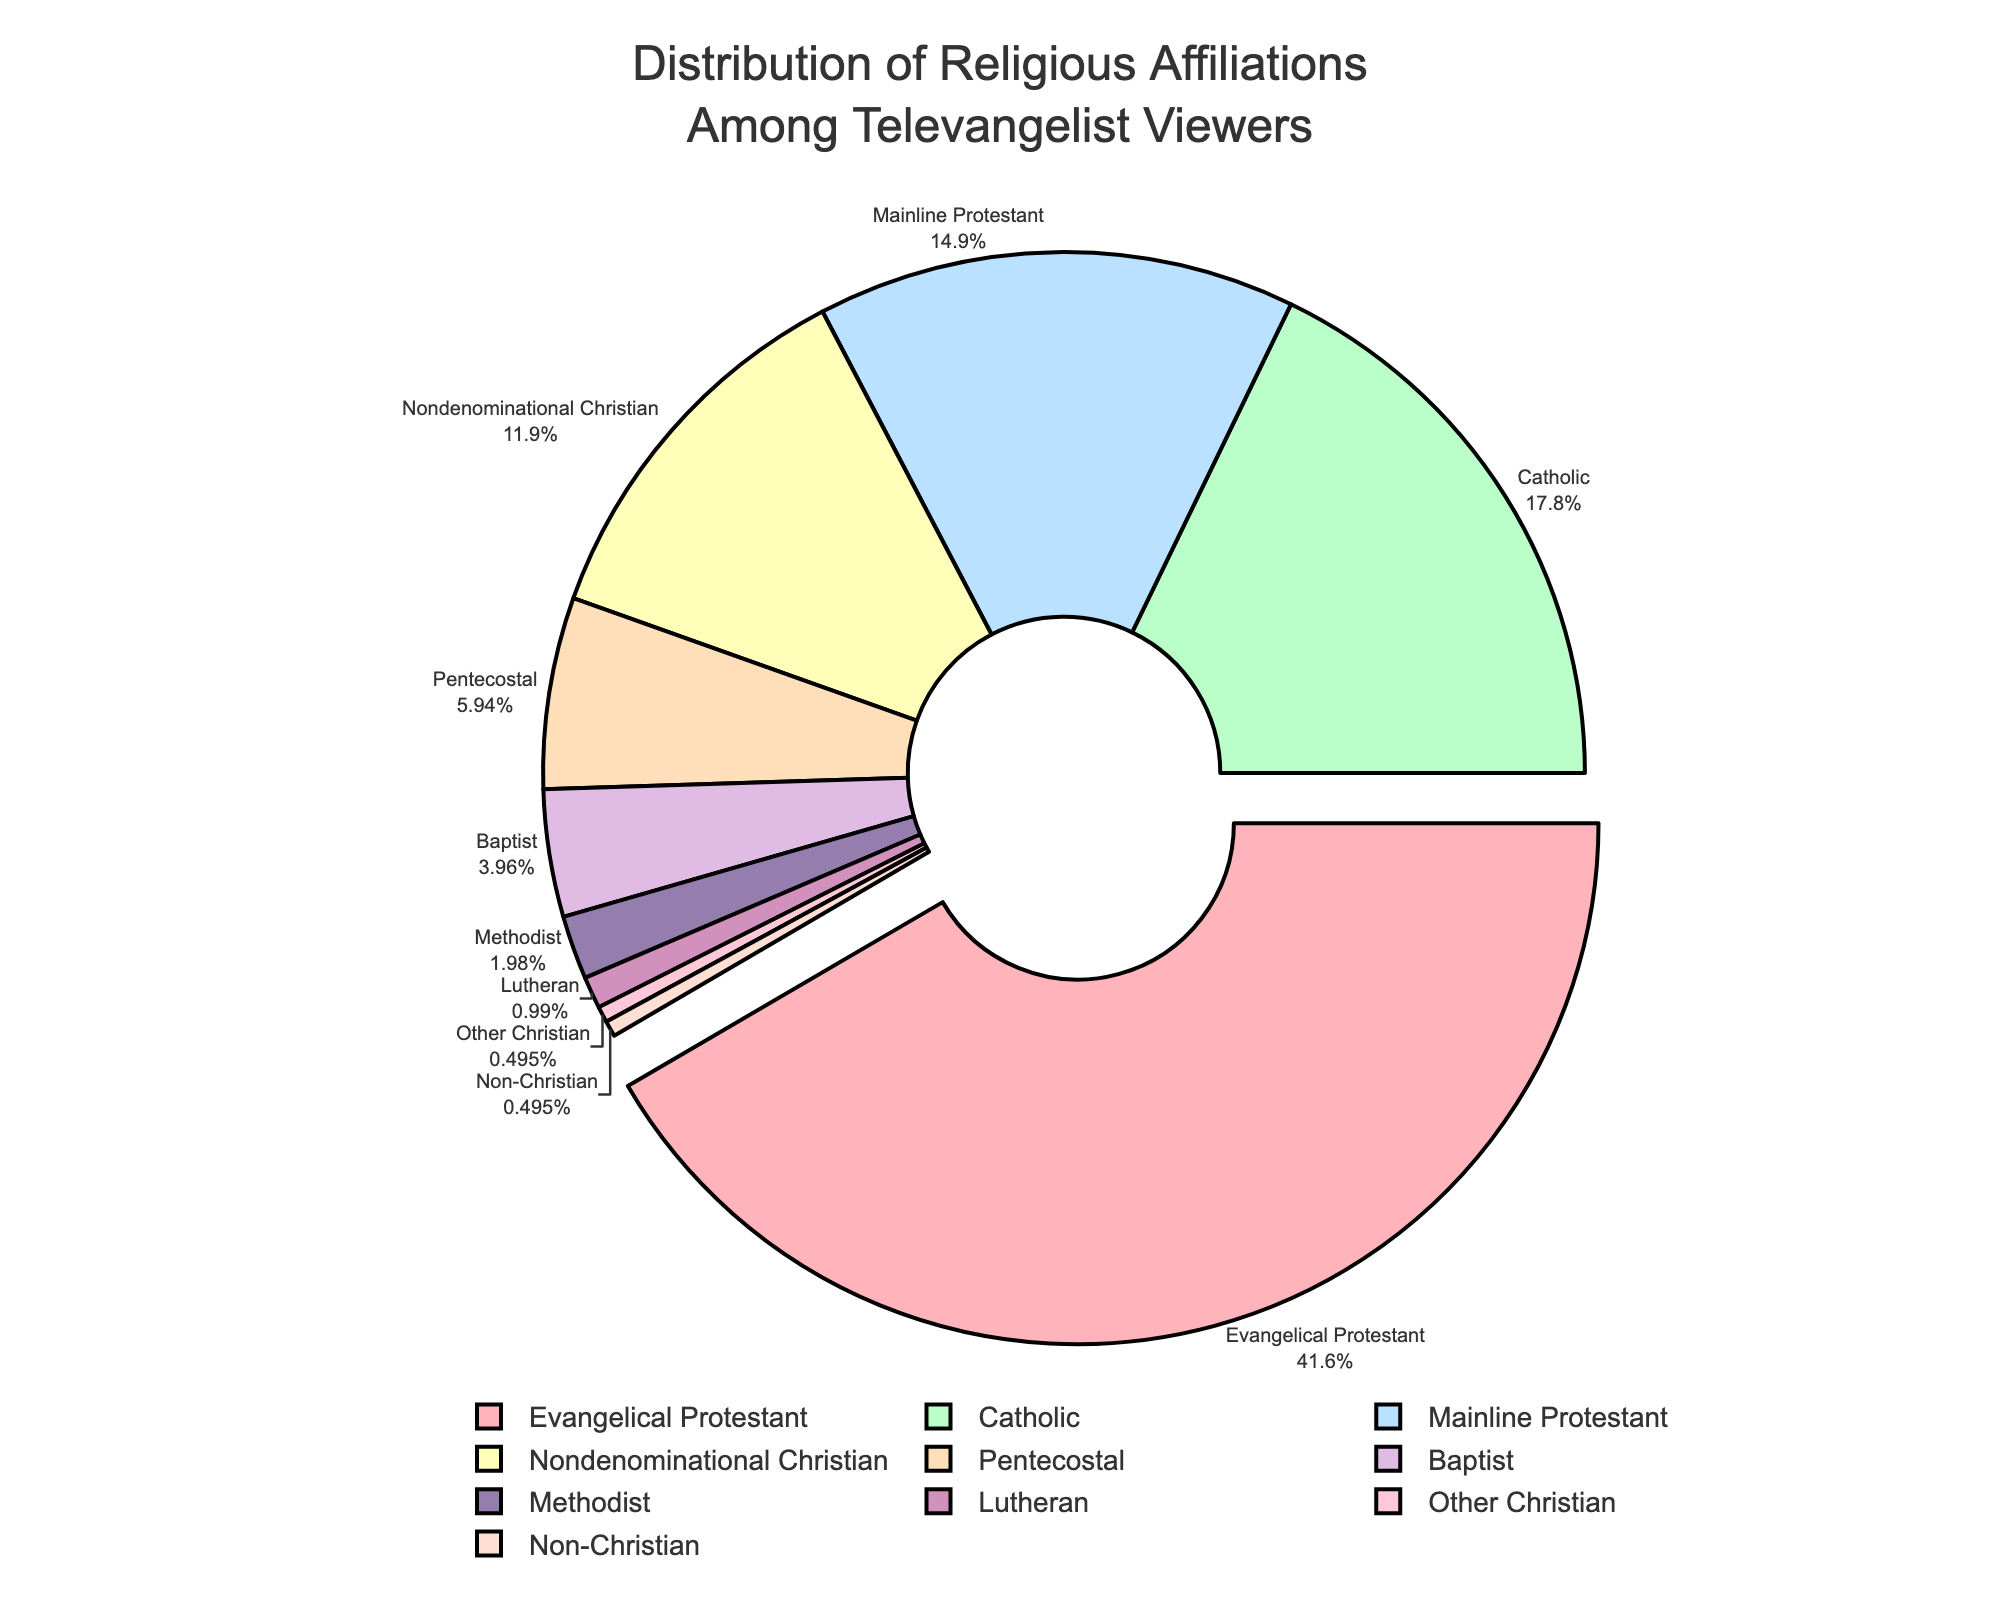Which religious affiliation has the highest percentage among televangelist viewers? To find this, we need to identify the segment with the highest percentage in the pie chart. The Evangelical Protestant segment has the largest slice at 42%.
Answer: Evangelical Protestant What is the combined percentage of Mainline Protestant and Nondenominational Christian viewers? First, find the percentages for Mainline Protestant (15%) and Nondenominational Christian (12%). Then sum them up: 15 + 12.
Answer: 27% How much larger is the percentage of Catholic viewers compared to Pentecostal viewers? First, find the percentages of both groups: Catholic (18%) and Pentecostal (6%). Subtract Pentecostal’s percentage from Catholic’s: 18 - 6.
Answer: 12% Which groups have a percentage that is less than or equal to 5%? Identify the segments with a percentage under or equal to 5%: Non-Christian (0.5%), Other Christian (0.5%), Lutheran (1%), and Methodist (2%).
Answer: Non-Christian, Other Christian, Lutheran, Methodist What is the percentage difference between Baptist and Methodist viewers? Find the percentages for Baptist (4%) and Methodist (2%). Subtract Methodist’s percentage from Baptist’s: 4 - 2.
Answer: 2% Which three groups have the smallest percentages, and what are their combined value? Identify the three groups with the smallest slices: Non-Christian (0.5%), Other Christian (0.5%), and Lutheran (1%). Sum their percentages: 0.5 + 0.5 + 1.
Answer: 2% Is the percentage of Evangelical Protestant viewers greater than the sum of Nondenominational Christian and Pentecostal viewers? Evangelical Protestant viewers are 42%. Sum Nondenominational Christian (12%) and Pentecostal (6%): 12 + 6 = 18%. Compare 42% to 18%.
Answer: Yes Which segment is highlighted or "pulled out" in the pie chart? From the visual, the segment that is pulled out is noticeable. It is the Evangelical Protestant segment, as indicated by its separation from the pie chart.
Answer: Evangelical Protestant 